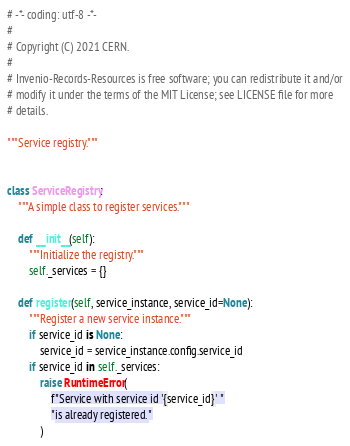Convert code to text. <code><loc_0><loc_0><loc_500><loc_500><_Python_># -*- coding: utf-8 -*-
#
# Copyright (C) 2021 CERN.
#
# Invenio-Records-Resources is free software; you can redistribute it and/or
# modify it under the terms of the MIT License; see LICENSE file for more
# details.

"""Service registry."""


class ServiceRegistry:
    """A simple class to register services."""

    def __init__(self):
        """Initialize the registry."""
        self._services = {}

    def register(self, service_instance, service_id=None):
        """Register a new service instance."""
        if service_id is None:
            service_id = service_instance.config.service_id
        if service_id in self._services:
            raise RuntimeError(
                f"Service with service id '{service_id}' "
                "is already registered."
            )</code> 